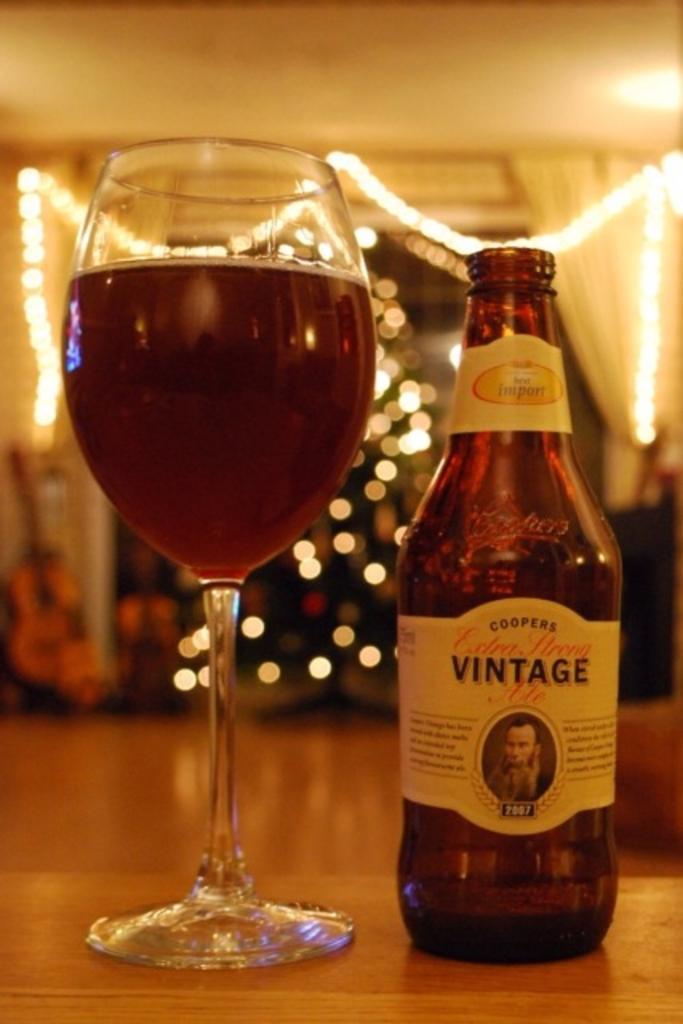Could you give a brief overview of what you see in this image? This image consists of a glass and a bottle. There is some liquid in glass. There are lights in the middle. 